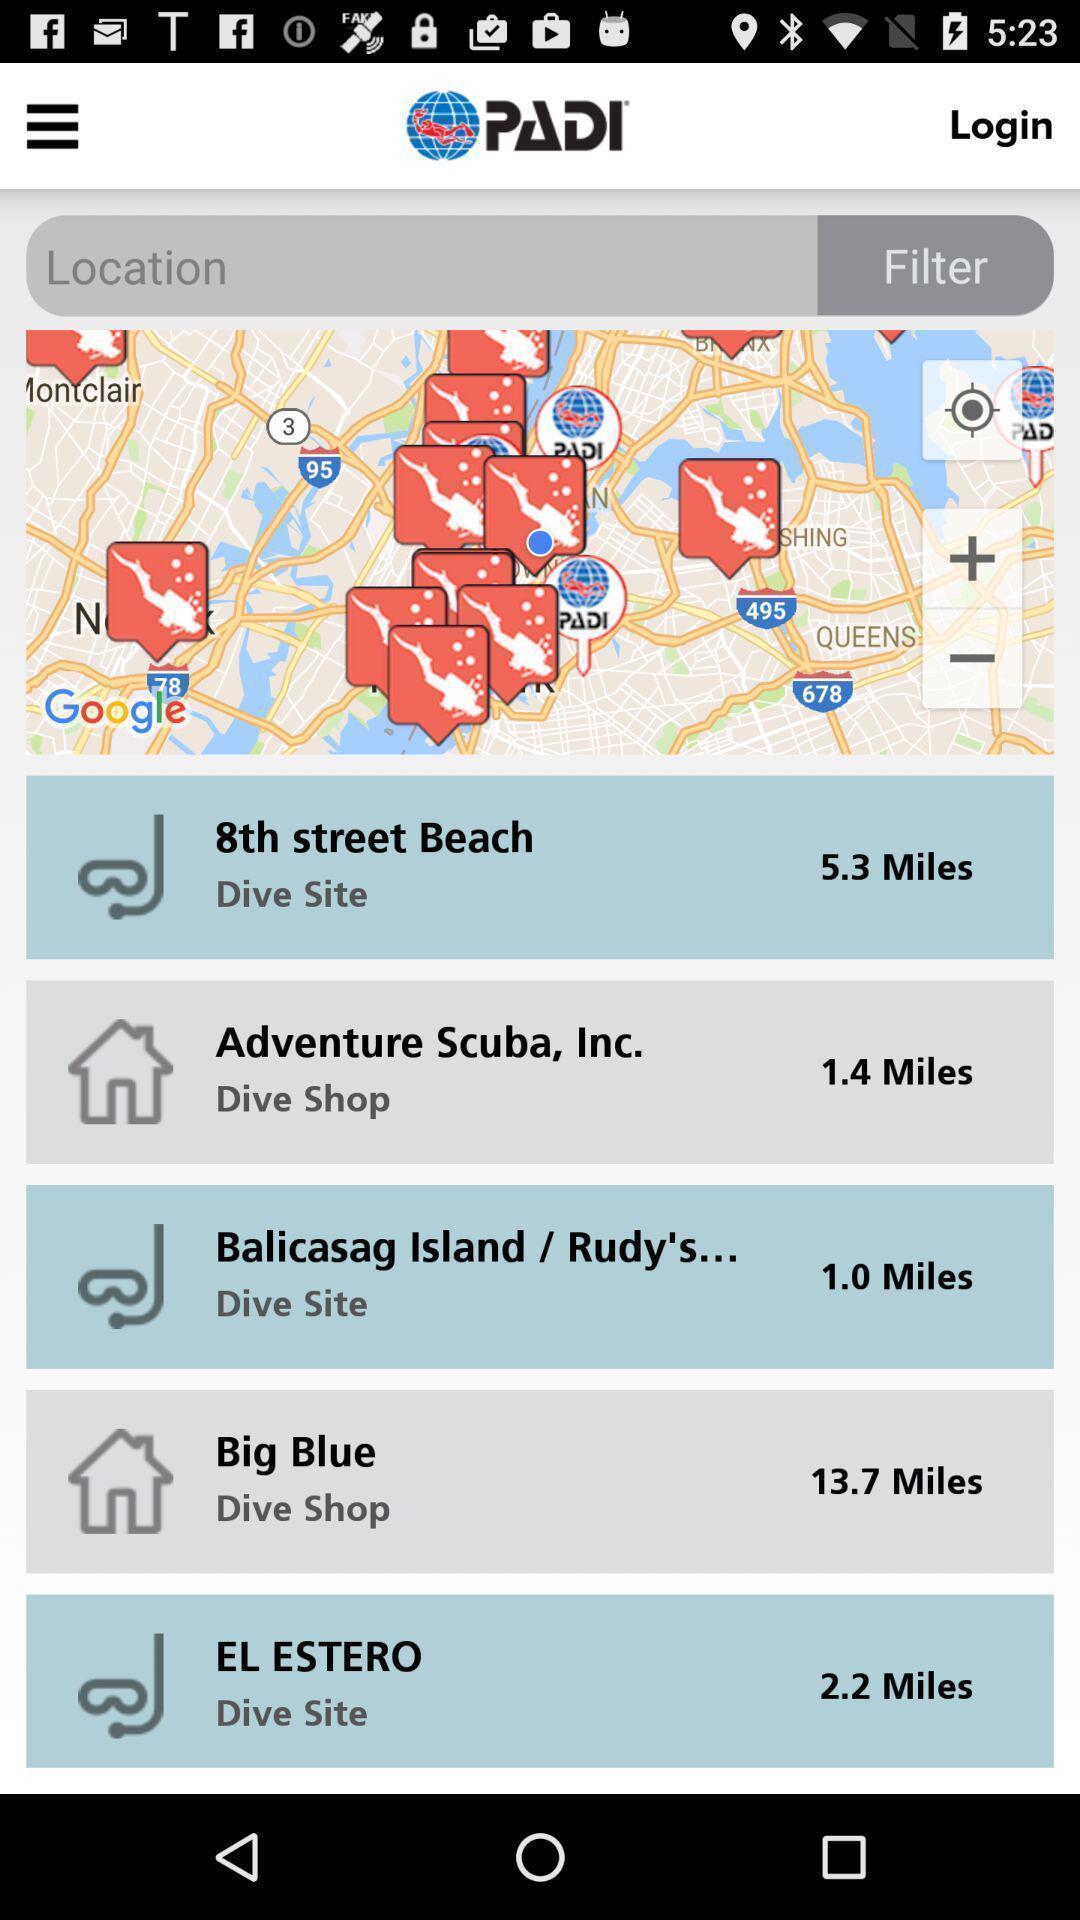Give me a summary of this screen capture. Page showing locations on a scuba diving app. 